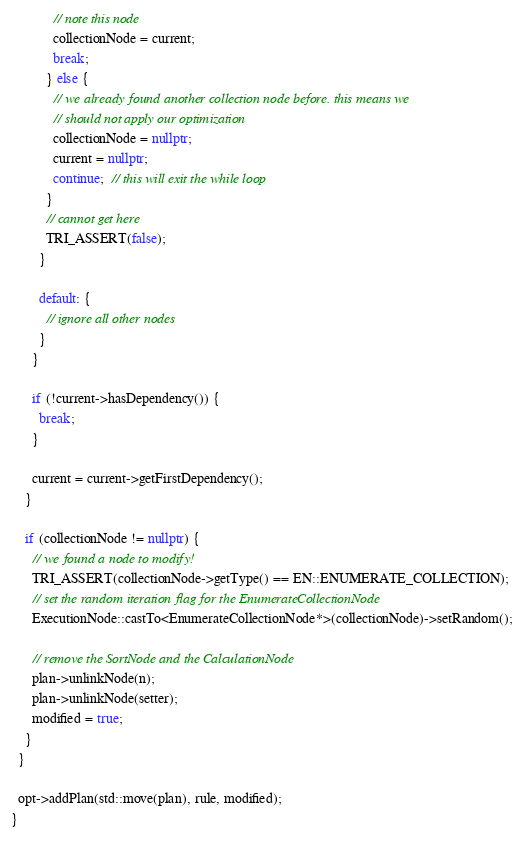Convert code to text. <code><loc_0><loc_0><loc_500><loc_500><_C++_>            // note this node
            collectionNode = current;
            break;
          } else {
            // we already found another collection node before. this means we
            // should not apply our optimization
            collectionNode = nullptr;
            current = nullptr;
            continue;  // this will exit the while loop
          }
          // cannot get here
          TRI_ASSERT(false);
        }

        default: {
          // ignore all other nodes
        }
      }

      if (!current->hasDependency()) {
        break;
      }

      current = current->getFirstDependency();
    }

    if (collectionNode != nullptr) {
      // we found a node to modify!
      TRI_ASSERT(collectionNode->getType() == EN::ENUMERATE_COLLECTION);
      // set the random iteration flag for the EnumerateCollectionNode
      ExecutionNode::castTo<EnumerateCollectionNode*>(collectionNode)->setRandom();

      // remove the SortNode and the CalculationNode
      plan->unlinkNode(n);
      plan->unlinkNode(setter);
      modified = true;
    }
  }

  opt->addPlan(std::move(plan), rule, modified);
}
</code> 